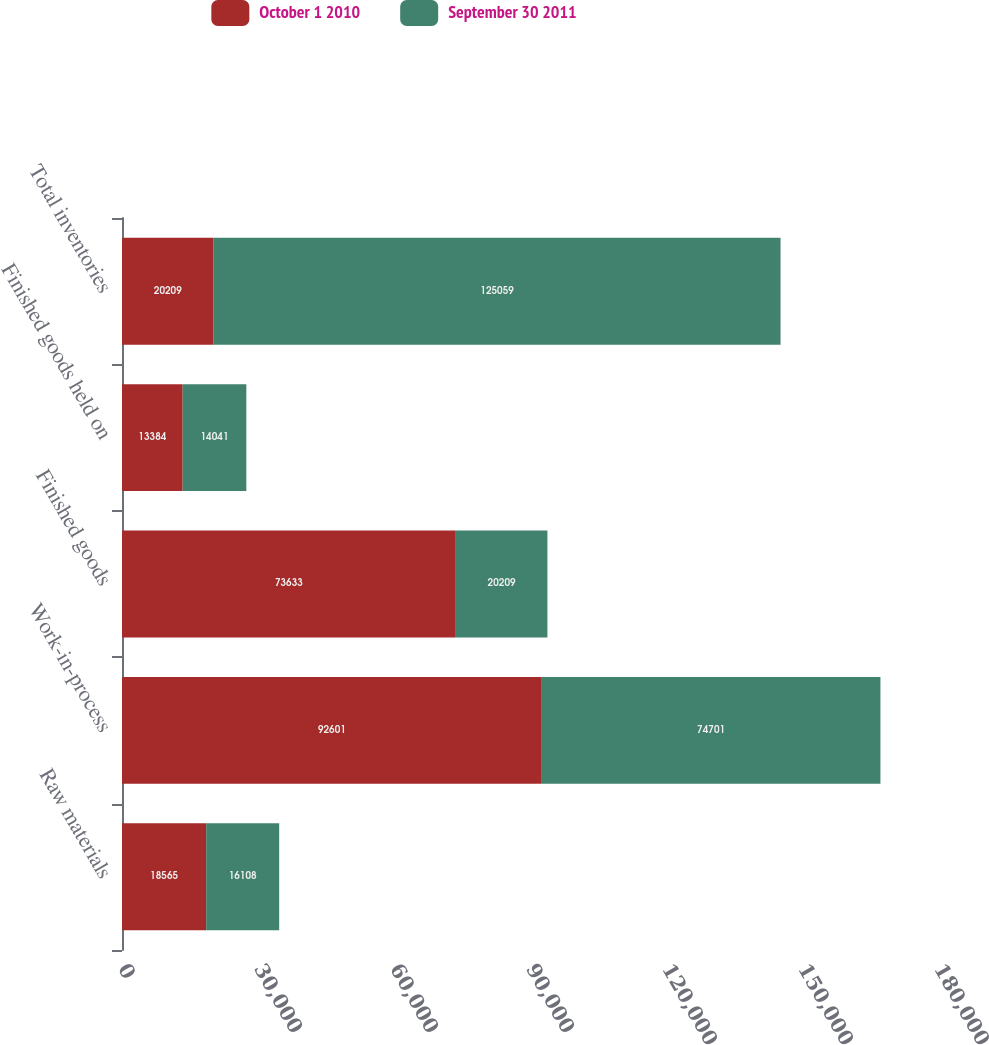Convert chart to OTSL. <chart><loc_0><loc_0><loc_500><loc_500><stacked_bar_chart><ecel><fcel>Raw materials<fcel>Work-in-process<fcel>Finished goods<fcel>Finished goods held on<fcel>Total inventories<nl><fcel>October 1 2010<fcel>18565<fcel>92601<fcel>73633<fcel>13384<fcel>20209<nl><fcel>September 30 2011<fcel>16108<fcel>74701<fcel>20209<fcel>14041<fcel>125059<nl></chart> 